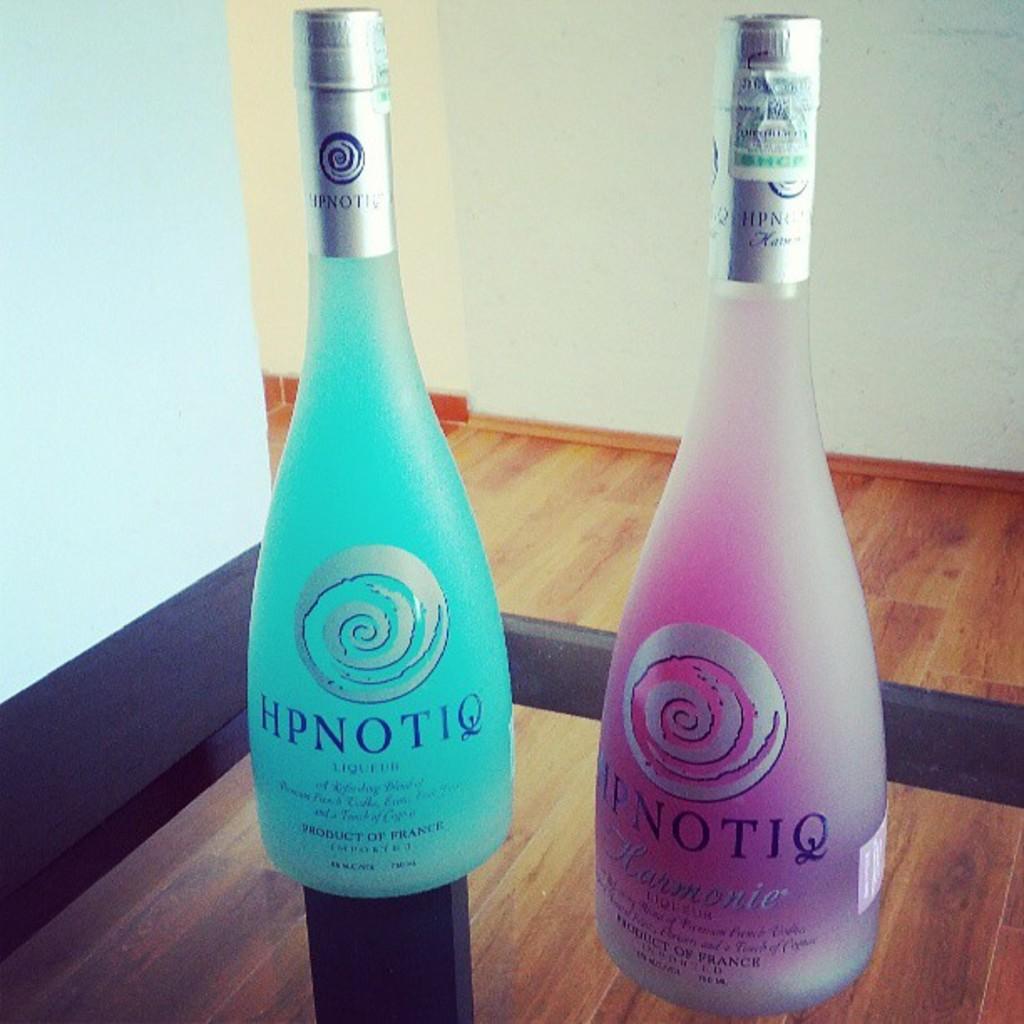What brand of wine is this?
Keep it short and to the point. Hpnotiq. Where was this beverage made?
Offer a very short reply. France. 